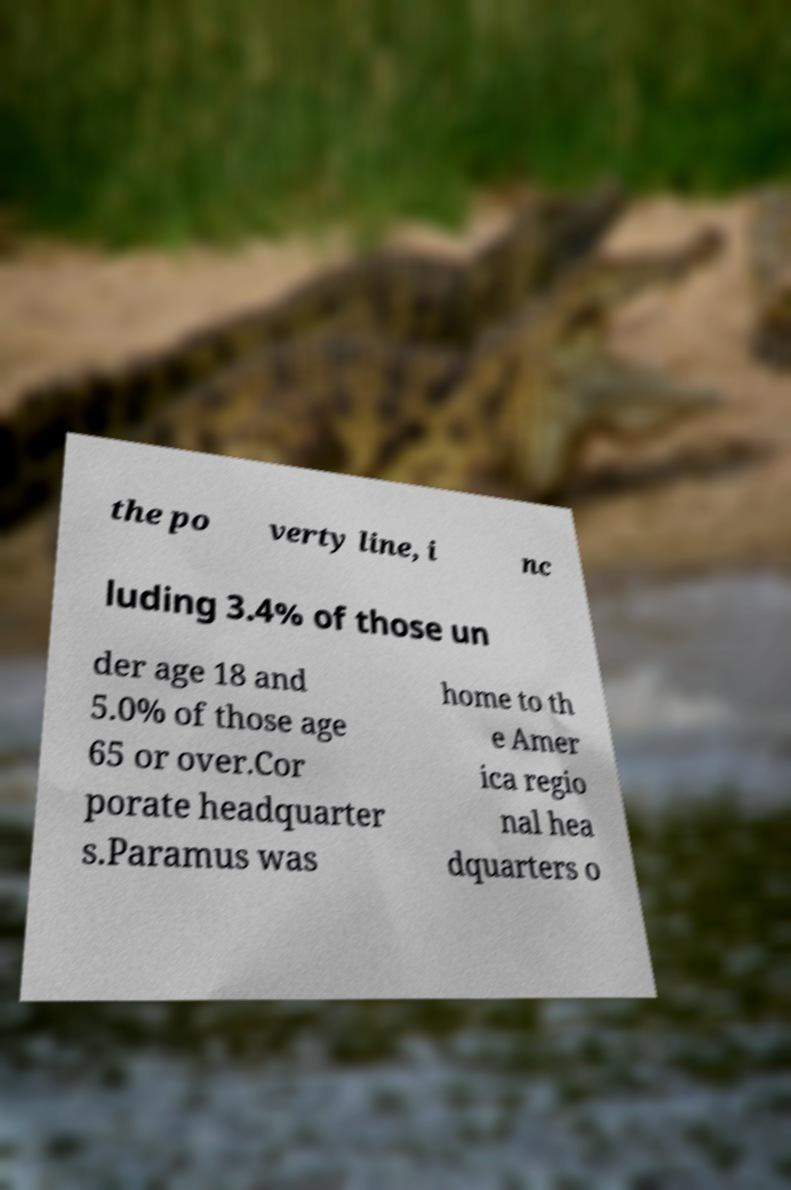Could you assist in decoding the text presented in this image and type it out clearly? the po verty line, i nc luding 3.4% of those un der age 18 and 5.0% of those age 65 or over.Cor porate headquarter s.Paramus was home to th e Amer ica regio nal hea dquarters o 